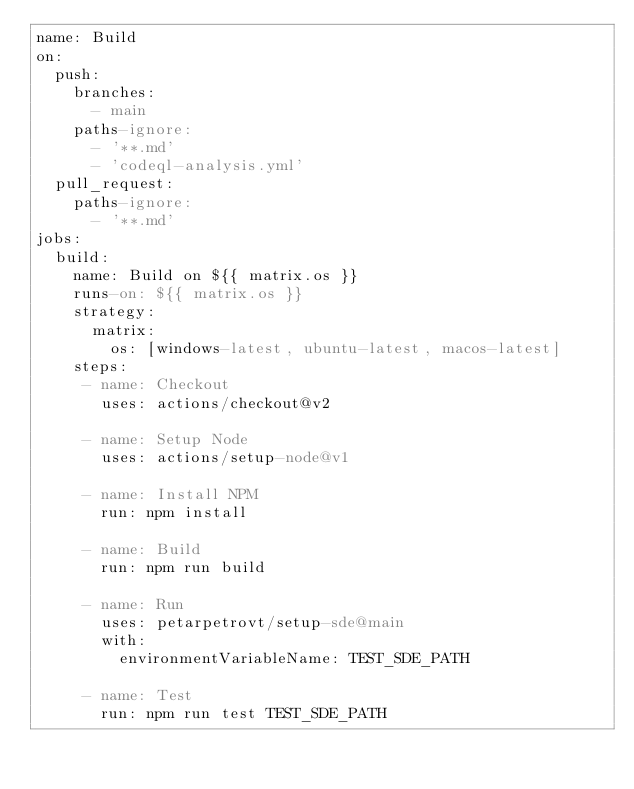<code> <loc_0><loc_0><loc_500><loc_500><_YAML_>name: Build
on:
  push:
    branches:
      - main
    paths-ignore:
      - '**.md'
      - 'codeql-analysis.yml'
  pull_request:
    paths-ignore:
      - '**.md'
jobs:
  build:
    name: Build on ${{ matrix.os }}
    runs-on: ${{ matrix.os }}
    strategy:
      matrix:
        os: [windows-latest, ubuntu-latest, macos-latest]
    steps:
     - name: Checkout
       uses: actions/checkout@v2

     - name: Setup Node
       uses: actions/setup-node@v1

     - name: Install NPM
       run: npm install

     - name: Build
       run: npm run build

     - name: Run
       uses: petarpetrovt/setup-sde@main
       with:
         environmentVariableName: TEST_SDE_PATH

     - name: Test
       run: npm run test TEST_SDE_PATH
</code> 